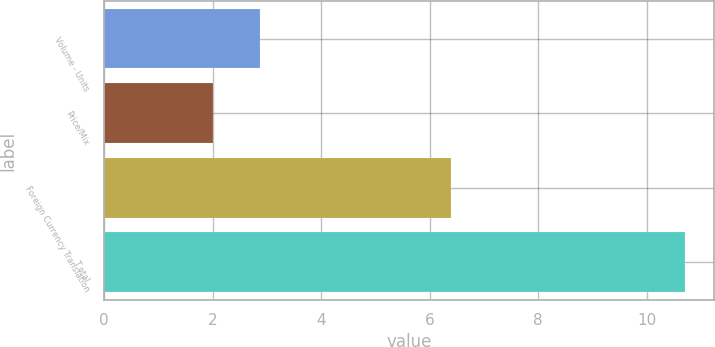<chart> <loc_0><loc_0><loc_500><loc_500><bar_chart><fcel>Volume - Units<fcel>Price/Mix<fcel>Foreign Currency Translation<fcel>T otal<nl><fcel>2.87<fcel>2<fcel>6.4<fcel>10.7<nl></chart> 